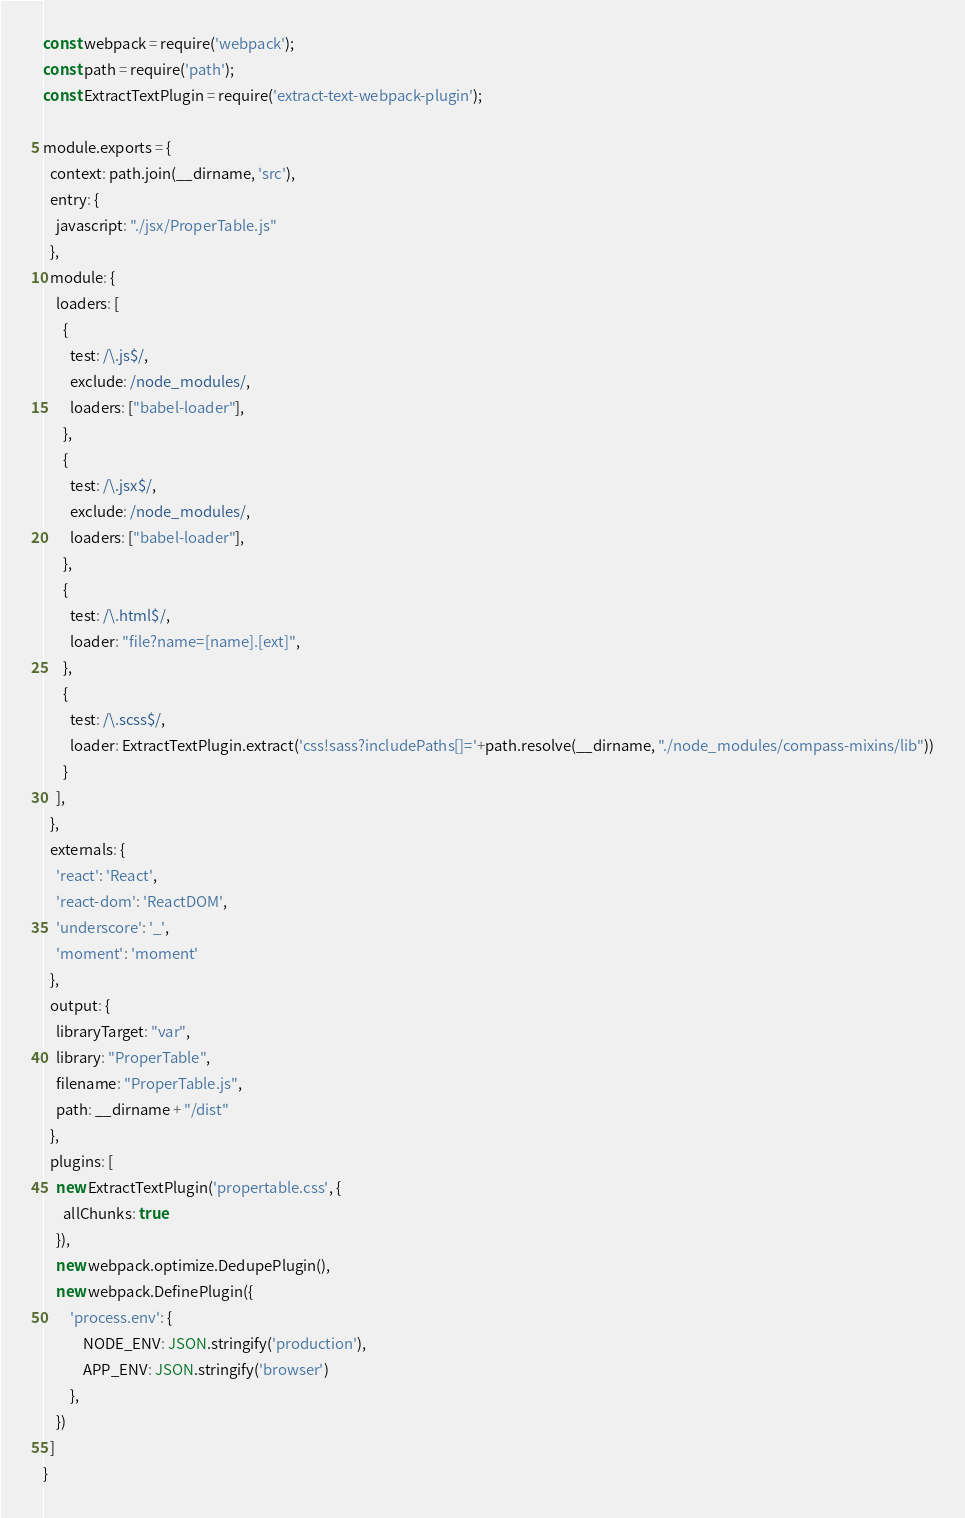Convert code to text. <code><loc_0><loc_0><loc_500><loc_500><_JavaScript_>const webpack = require('webpack');
const path = require('path');
const ExtractTextPlugin = require('extract-text-webpack-plugin');

module.exports = {
  context: path.join(__dirname, 'src'),
  entry: {
    javascript: "./jsx/ProperTable.js"
  },
  module: {
    loaders: [
      {
        test: /\.js$/,
        exclude: /node_modules/,
        loaders: ["babel-loader"],
      },
      {
        test: /\.jsx$/,
        exclude: /node_modules/,
        loaders: ["babel-loader"],
      },
      {
        test: /\.html$/,
        loader: "file?name=[name].[ext]",
      },
      {
        test: /\.scss$/,
        loader: ExtractTextPlugin.extract('css!sass?includePaths[]='+path.resolve(__dirname, "./node_modules/compass-mixins/lib"))
      }
    ],
  },
  externals: {
    'react': 'React',
    'react-dom': 'ReactDOM',
    'underscore': '_',
    'moment': 'moment'
  },
  output: {
    libraryTarget: "var",
    library: "ProperTable",
    filename: "ProperTable.js",
    path: __dirname + "/dist"
  },
  plugins: [
    new ExtractTextPlugin('propertable.css', {
      allChunks: true
    }),
    new webpack.optimize.DedupePlugin(),
    new webpack.DefinePlugin({
        'process.env': {
            NODE_ENV: JSON.stringify('production'),
            APP_ENV: JSON.stringify('browser')
        },
    })
  ]
}</code> 